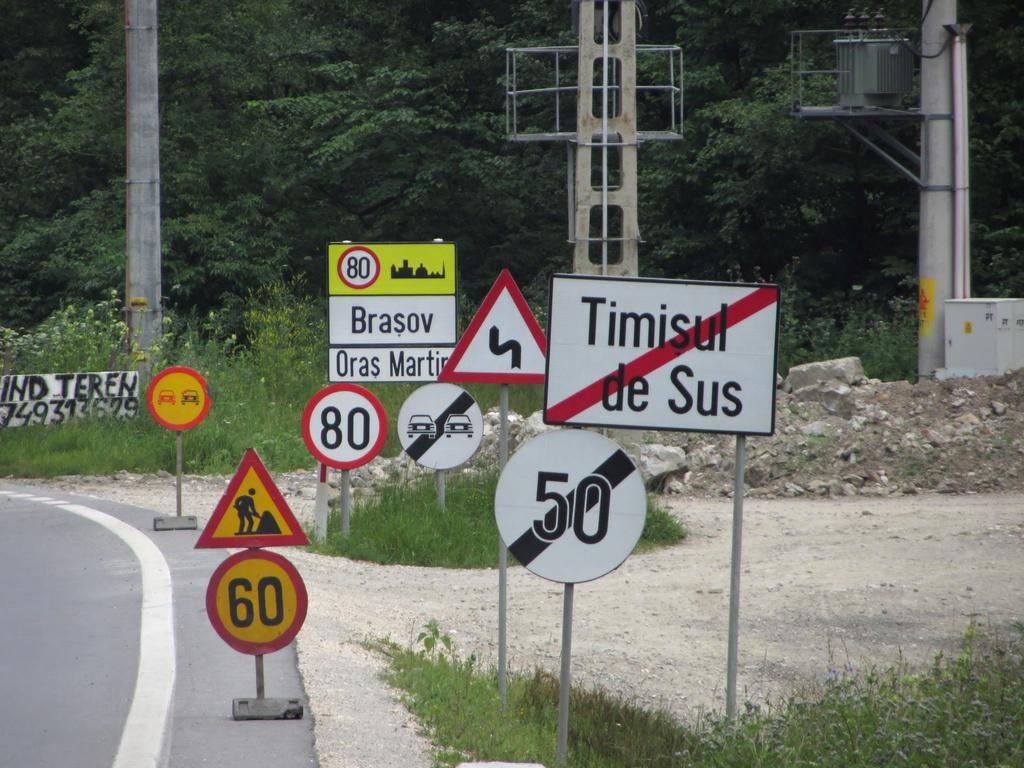<image>
Offer a succinct explanation of the picture presented. Multiple different road signs such as one stating, Timisul de sus, on the right side of the road. 